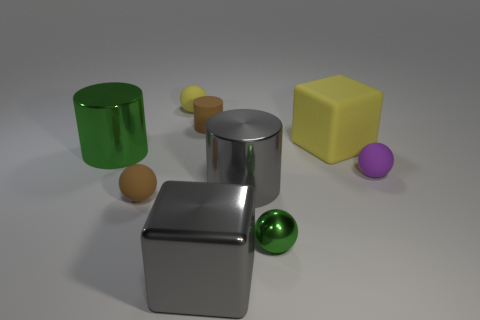Add 1 shiny cylinders. How many objects exist? 10 Subtract all cylinders. How many objects are left? 6 Add 7 purple balls. How many purple balls exist? 8 Subtract 0 blue cylinders. How many objects are left? 9 Subtract all blue metallic cubes. Subtract all brown cylinders. How many objects are left? 8 Add 8 big gray cylinders. How many big gray cylinders are left? 9 